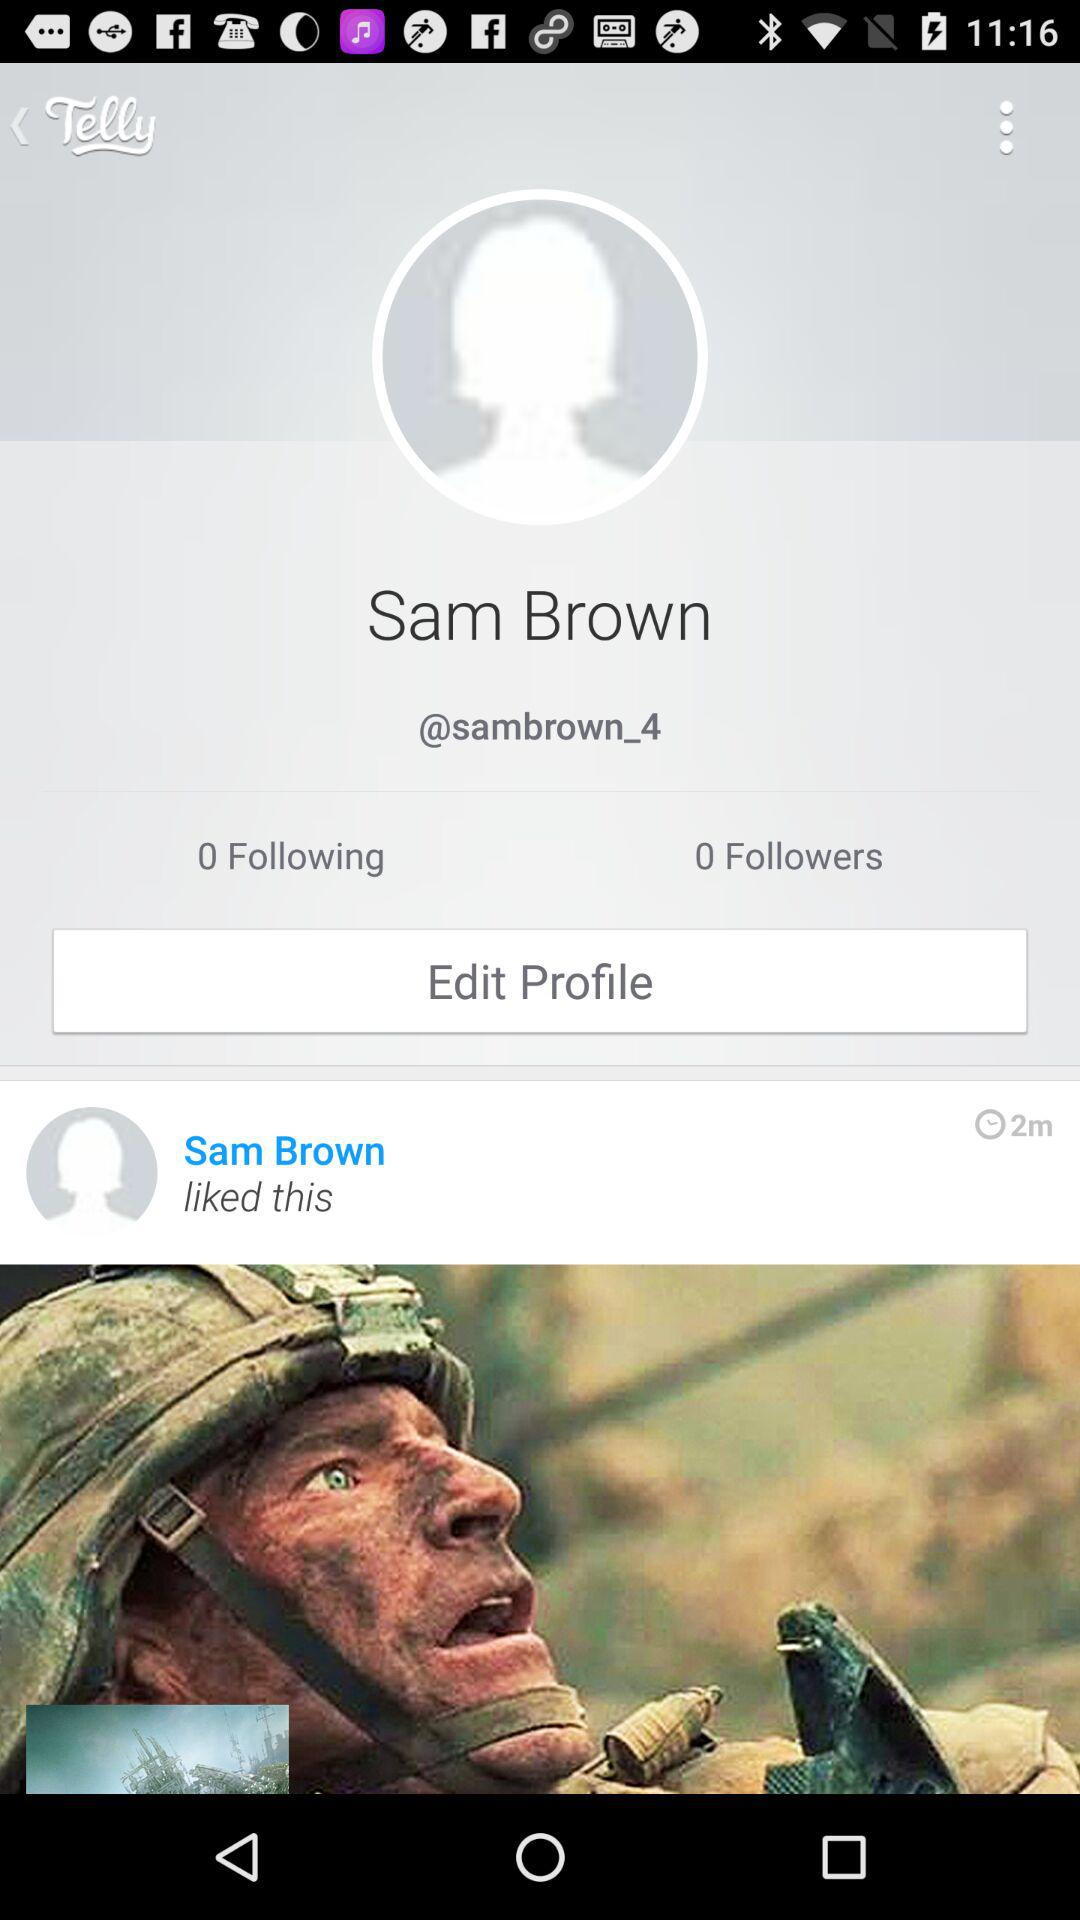What is the application name? The application name is "Telly". 